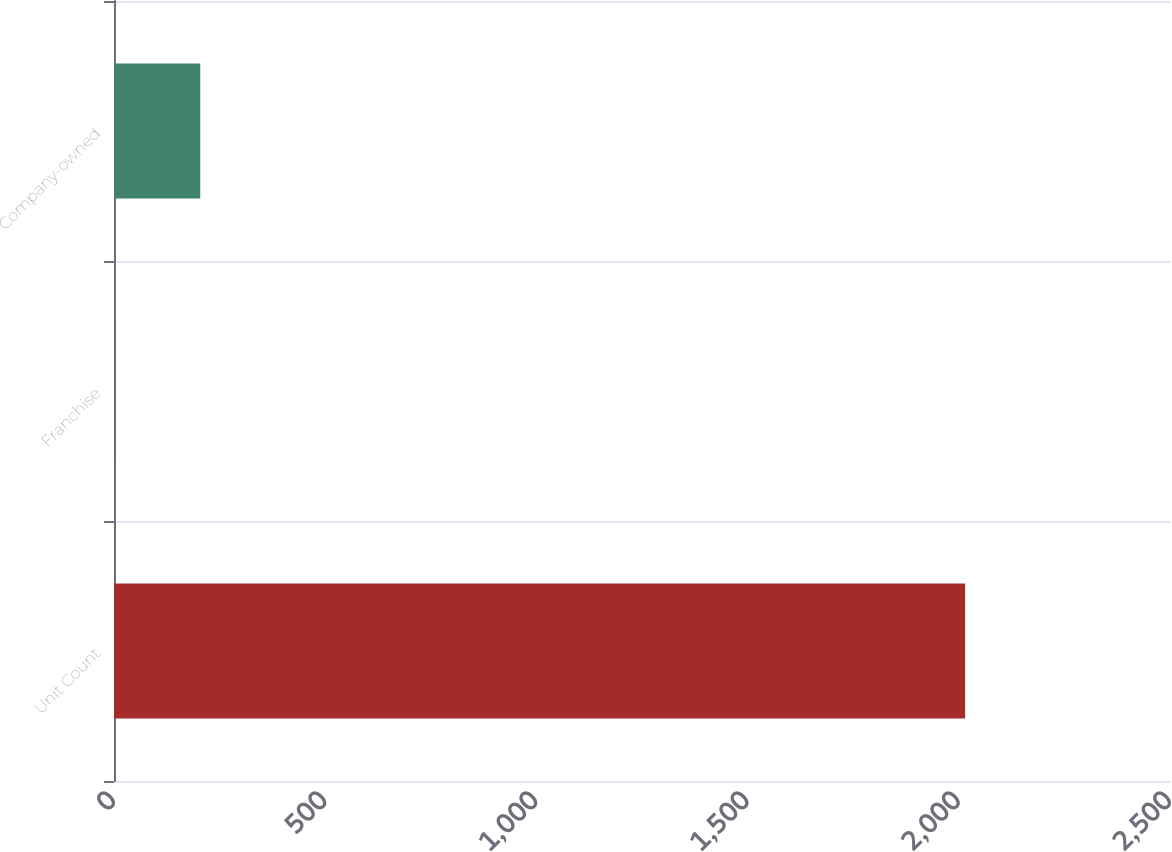<chart> <loc_0><loc_0><loc_500><loc_500><bar_chart><fcel>Unit Count<fcel>Franchise<fcel>Company-owned<nl><fcel>2015<fcel>3<fcel>204.2<nl></chart> 